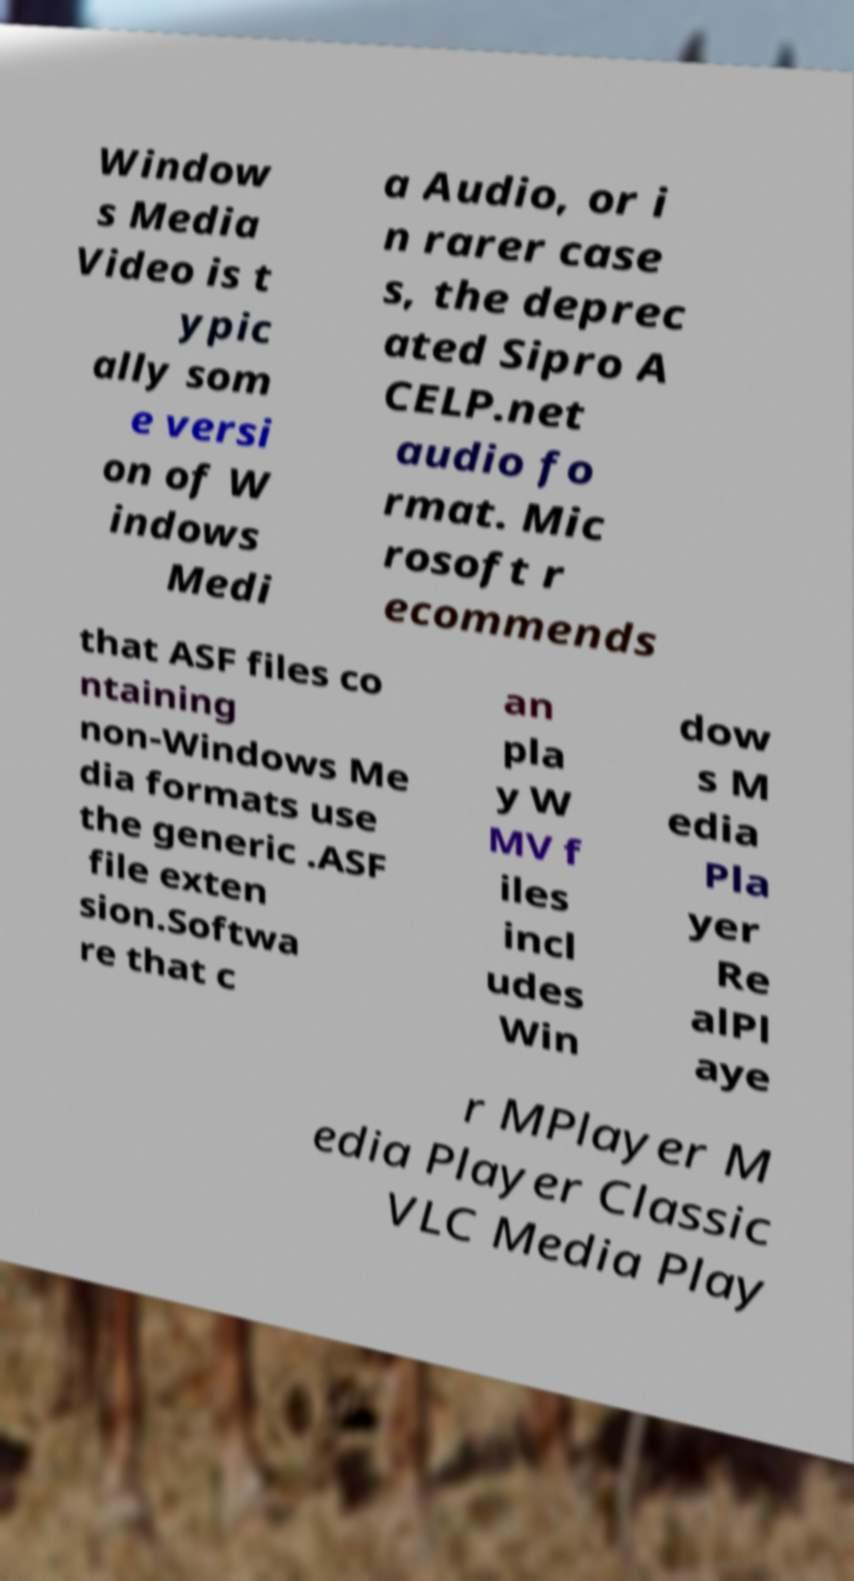Could you extract and type out the text from this image? Window s Media Video is t ypic ally som e versi on of W indows Medi a Audio, or i n rarer case s, the deprec ated Sipro A CELP.net audio fo rmat. Mic rosoft r ecommends that ASF files co ntaining non-Windows Me dia formats use the generic .ASF file exten sion.Softwa re that c an pla y W MV f iles incl udes Win dow s M edia Pla yer Re alPl aye r MPlayer M edia Player Classic VLC Media Play 